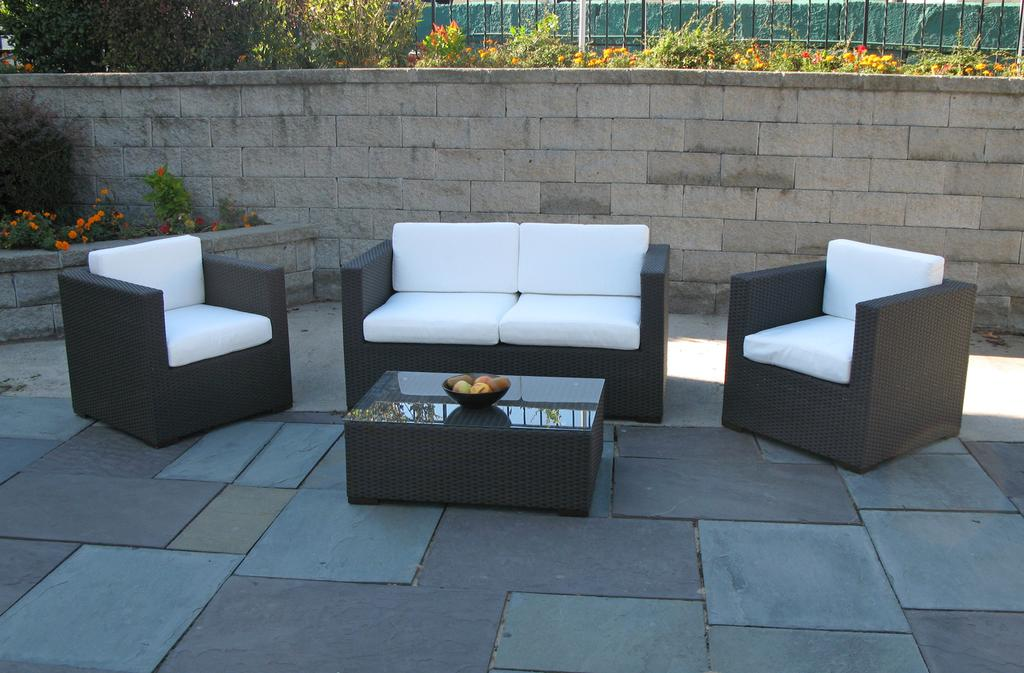What type of vegetation can be seen in the image? There are trees and plants in the image. What architectural features are present in the image? There is a fence and a wall in the image. How many sofas are visible in the image? There are three sofas in the image. What is placed in front of the sofa? There is a bowl in front of the sofa. What is inside the bowl? The bowl contains fruits. How many lizards are sitting on the wall in the image? There are no lizards present in the image. What is the color of the knee of the person sitting on the sofa? There are no people visible in the image, so it is impossible to determine the color of anyone's knee. 